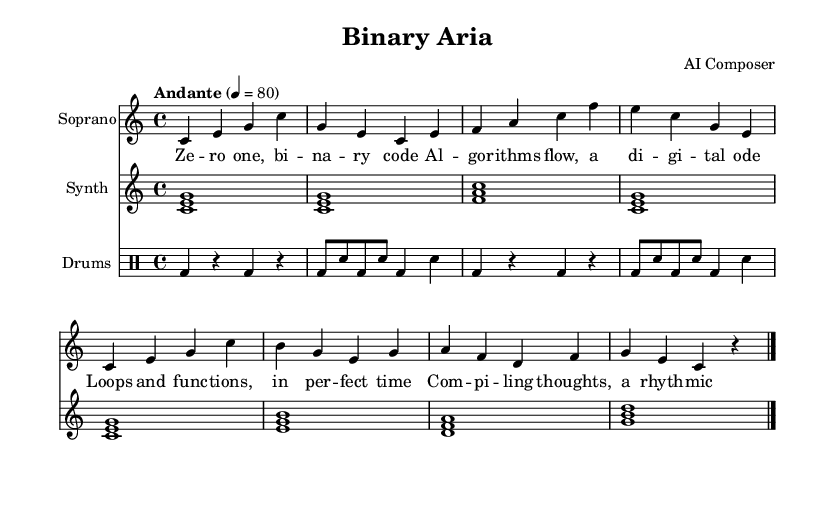What is the key signature of this music? The key signature is indicated at the beginning of the score. It is C major, which has no sharps or flats.
Answer: C major What is the time signature of this music? The time signature is shown at the beginning of the score, appearing as a fraction. It indicates four beats per measure, represented as 4/4.
Answer: 4/4 What is the tempo marking for this music? The tempo marking is located in the first system of the score, and it states "Andante" with a metronome marking of 80 beats per minute.
Answer: Andante, 80 How many measures are in the soprano voice part? To determine this, we count the individual measures in the soprano voice part. There are eight measures outlined in the music.
Answer: Eight What is the primary theme expressed in the lyrics? The lyrics reflect a theme of technology and coding, focusing on concepts like binary code and algorithms, which are articulated in each line.
Answer: Technology and coding What type of accompaniment is used for this opera? Looking at the score, the accompaniment consists of synthesizer sounds, indicated in the designated part for the synth instrument.
Answer: Synthesizer How do the rhythms in the drum part contribute to the overall feel of the piece? The drum part utilizes a mix of bass drum and snare drum patterns to create a rhythmic foundation that complements the electronic and melodic elements, enhancing the drive of the piece.
Answer: Rhythmic foundation 